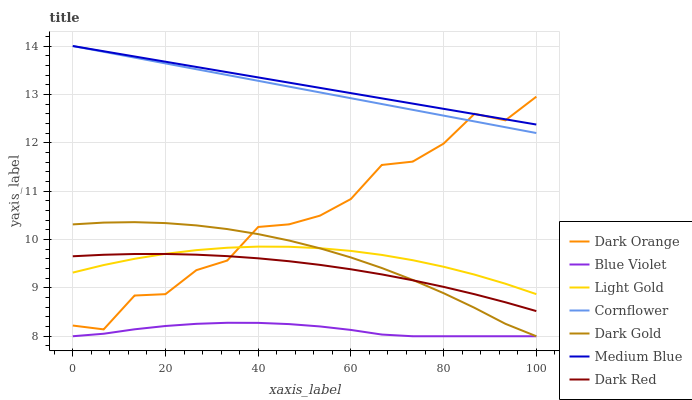Does Dark Gold have the minimum area under the curve?
Answer yes or no. No. Does Dark Gold have the maximum area under the curve?
Answer yes or no. No. Is Dark Gold the smoothest?
Answer yes or no. No. Is Dark Gold the roughest?
Answer yes or no. No. Does Dark Red have the lowest value?
Answer yes or no. No. Does Dark Gold have the highest value?
Answer yes or no. No. Is Blue Violet less than Dark Red?
Answer yes or no. Yes. Is Medium Blue greater than Dark Gold?
Answer yes or no. Yes. Does Blue Violet intersect Dark Red?
Answer yes or no. No. 